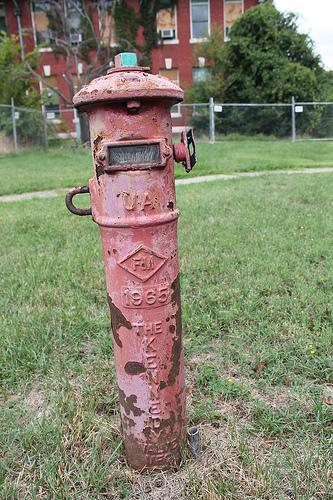Question: what is covering the corner of the building?
Choices:
A. Bushes.
B. Trees.
C. Cars.
D. Motorcycles.
Answer with the letter. Answer: B Question: what date is on the fire hydrant?
Choices:
A. 1979.
B. 1984.
C. 1965.
D. 1998.
Answer with the letter. Answer: C Question: where are the air conditioners?
Choices:
A. Windows.
B. On the wall.
C. Ceilings.
D. On the floor.
Answer with the letter. Answer: A Question: what kind of fence is there?
Choices:
A. Plastic.
B. Metal.
C. Rubber.
D. Steel.
Answer with the letter. Answer: B 